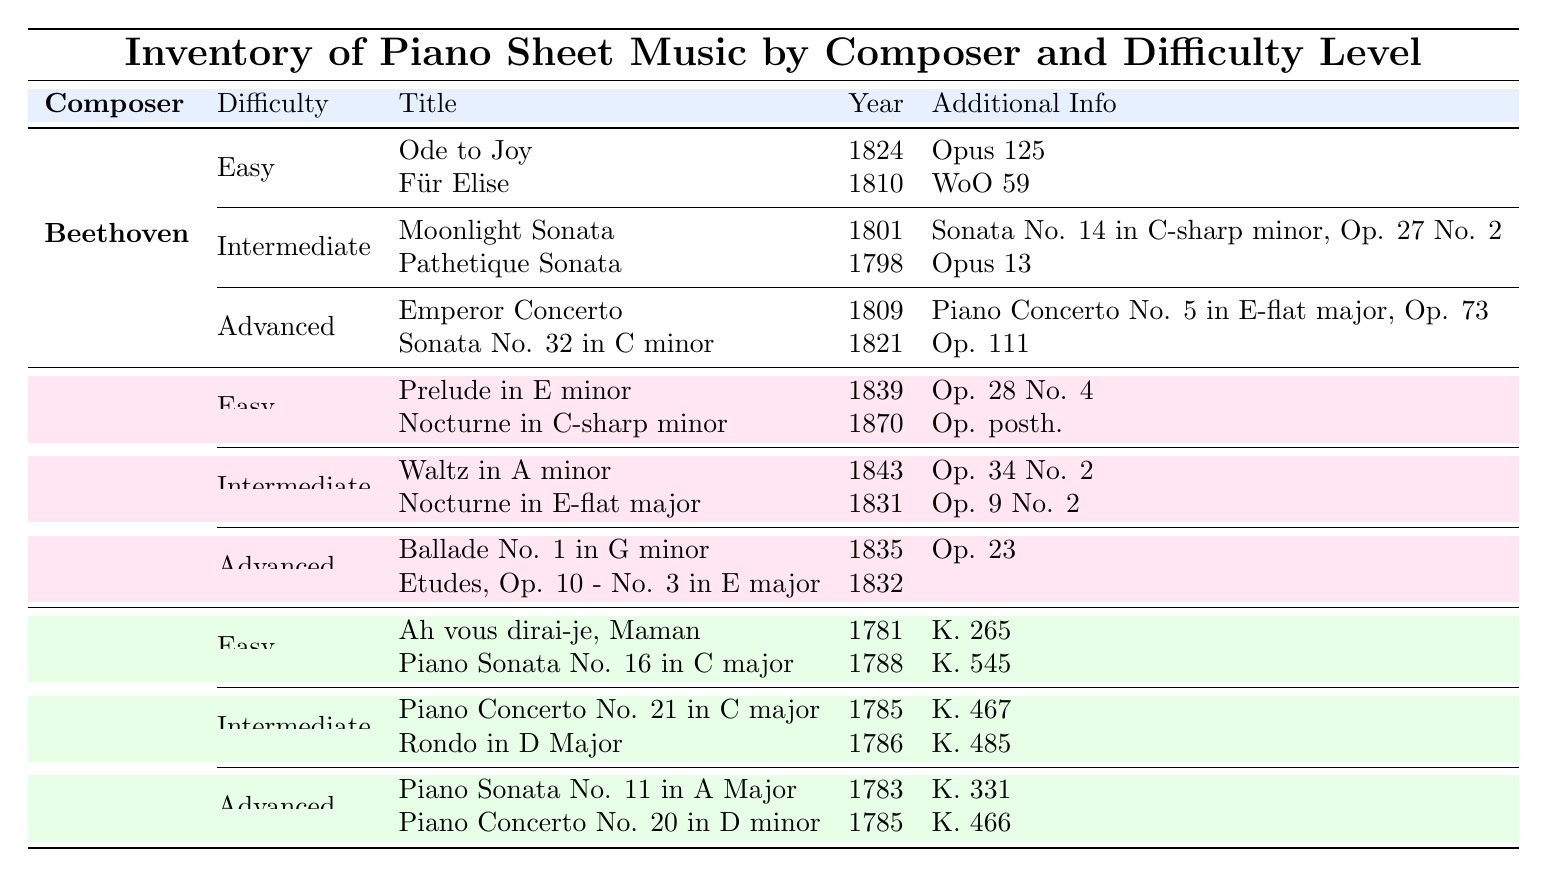What are the titles of the easy pieces by Beethoven? The easy pieces by Beethoven listed in the table are "Ode to Joy" and "Für Elise." I can find these titles under the Beethoven section and the Easy difficulty category.
Answer: Ode to Joy, Für Elise Which composer has works listed under the Advanced difficulty level? The composers with pieces under the Advanced difficulty level are Beethoven, Chopin, and Mozart. I see that each of these composers has titles categorized as Advanced in the table.
Answer: Beethoven, Chopin, Mozart Is "Sonata No. 14 in C-sharp minor" an advanced piece? "Sonata No. 14 in C-sharp minor" is actually listed as an Intermediate piece in the table, specifically under Beethoven. Therefore, the statement is false.
Answer: No How many easy pieces does Chopin have? Chopin has two easy pieces listed in the table: "Prelude in E minor" and "Nocturne in C-sharp minor." I find these two titles in the Easy category under the Chopin section, making the total count two.
Answer: 2 Which piece by Mozart was composed in 1785? The pieces by Mozart composed in 1785 are "Piano Concerto No. 21 in C major" and "Piano Concerto No. 20 in D minor." I can find both in the Intermediate and Advanced categories, respectively, listed in the correct year.
Answer: Piano Concerto No. 21 in C major, Piano Concerto No. 20 in D minor What is the youngest piece in the table and who is the composer? The youngest piece in the table is "Nocturne in C-sharp minor," composed in 1870 by Chopin. To find this, I check the years of all pieces, and 1870 is the latest year listed.
Answer: Nocturne in C-sharp minor, Chopin Are there any advanced pieces by Chopin that are not published under an opus? Yes, the composition "Etudes, Op. 10 - No. 3 in E major" does not have an associated opus number listed in the table. I look under the Advanced pieces of Chopin, where I see this specific title does not mention any opus.
Answer: Yes What is the average number of pieces across all difficulty levels for Beethoven? Beethoven has a total of 6 pieces: 2 easy, 2 intermediate, and 2 advanced. To find the average, I sum these pieces (2 + 2 + 2 = 6) and divide by the number of difficulty levels (3), getting an average of 6 / 3 = 2.
Answer: 2 Which two composers have pieces titled "Sonata"? The two composers with pieces titled "Sonata" are Beethoven and Mozart. Beethoven has "Sonata No. 14 in C-sharp minor" and "Sonata No. 32 in C minor," while Mozart has "Piano Sonata No. 16 in C major." I identify these pieces by scanning the table for the word "Sonata."
Answer: Beethoven, Mozart 